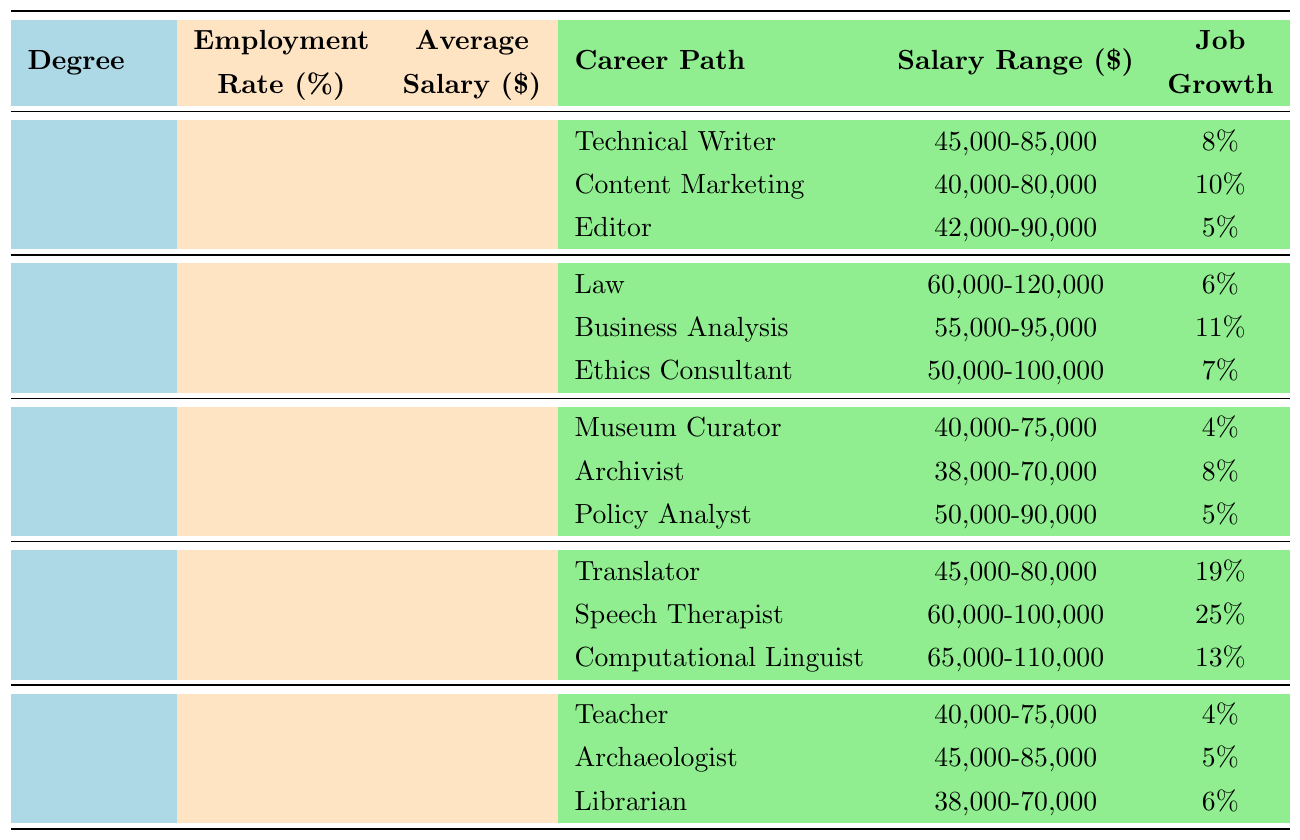What is the highest employment rate among the degrees listed? The table indicates the employment rates for each degree: English (91.5%), Philosophy (93.2%), History (92.1%), Linguistics (94.8%), and Classics (90.3%). The highest rate is for Linguistics at 94.8%.
Answer: 94.8% Which degree has the lowest average salary? The table shows the average salaries: English ($48,000), Philosophy ($51,000), History ($49,500), Linguistics ($52,500), and Classics ($47,000). The lowest average salary is for Classics at $47,000.
Answer: $47,000 True or False: The average salary for Philosophy graduates is higher than that for History graduates. The average salaries are Philosophy ($51,000) and History ($49,500). Since $51,000 is greater than $49,500, the statement is true.
Answer: True How much higher is the average salary of Linguistics compared to English? The average salary for Linguistics is $52,500 and for English is $48,000. The difference is calculated as $52,500 - $48,000 = $4,500.
Answer: $4,500 What is the average job growth for all the degrees listed? The job growth rates are: English (8%), Philosophy (6%), History (5%), Linguistics (19%), and Classics (4%). The sum of these is 8 + 6 + 5 + 19 + 4 = 42%. There are 5 degrees, so the average is 42% / 5 = 8.4%.
Answer: 8.4% Which career path under Philosophy has the highest salary range? The career paths and their salary ranges under Philosophy are: Law ($60,000-$120,000), Business Analysis ($55,000-$95,000), and Ethics Consultant ($50,000-$100,000). The highest salary range is for Law at $60,000-$120,000.
Answer: Law ($60,000-$120,000) Does Linguistics have a higher employment rate than English? The employment rates are Linguistics (94.8%) and English (91.5%). Since 94.8% is greater than 91.5%, the answer is yes.
Answer: Yes Which degree offers the highest job growth for a career path? The job growth rates for career paths are: Translator (19%), Speech Therapist (25%), and Computational Linguist (13%) for Linguistics; and for Philosophy: Business Analysis (11%). The highest growth is for Speech Therapist at 25%.
Answer: Speech Therapist (25%) What percentage difference in employment rate exists between Classics and Linguistics? The employment rate for Classics is 90.3% and for Linguistics is 94.8%. The difference is calculated as 94.8% - 90.3% = 4.5%.
Answer: 4.5% 